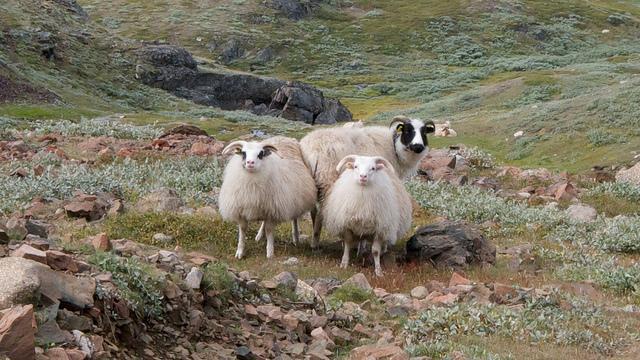How many sheeps are this?
Give a very brief answer. 3. How many sheep are visible?
Give a very brief answer. 3. 